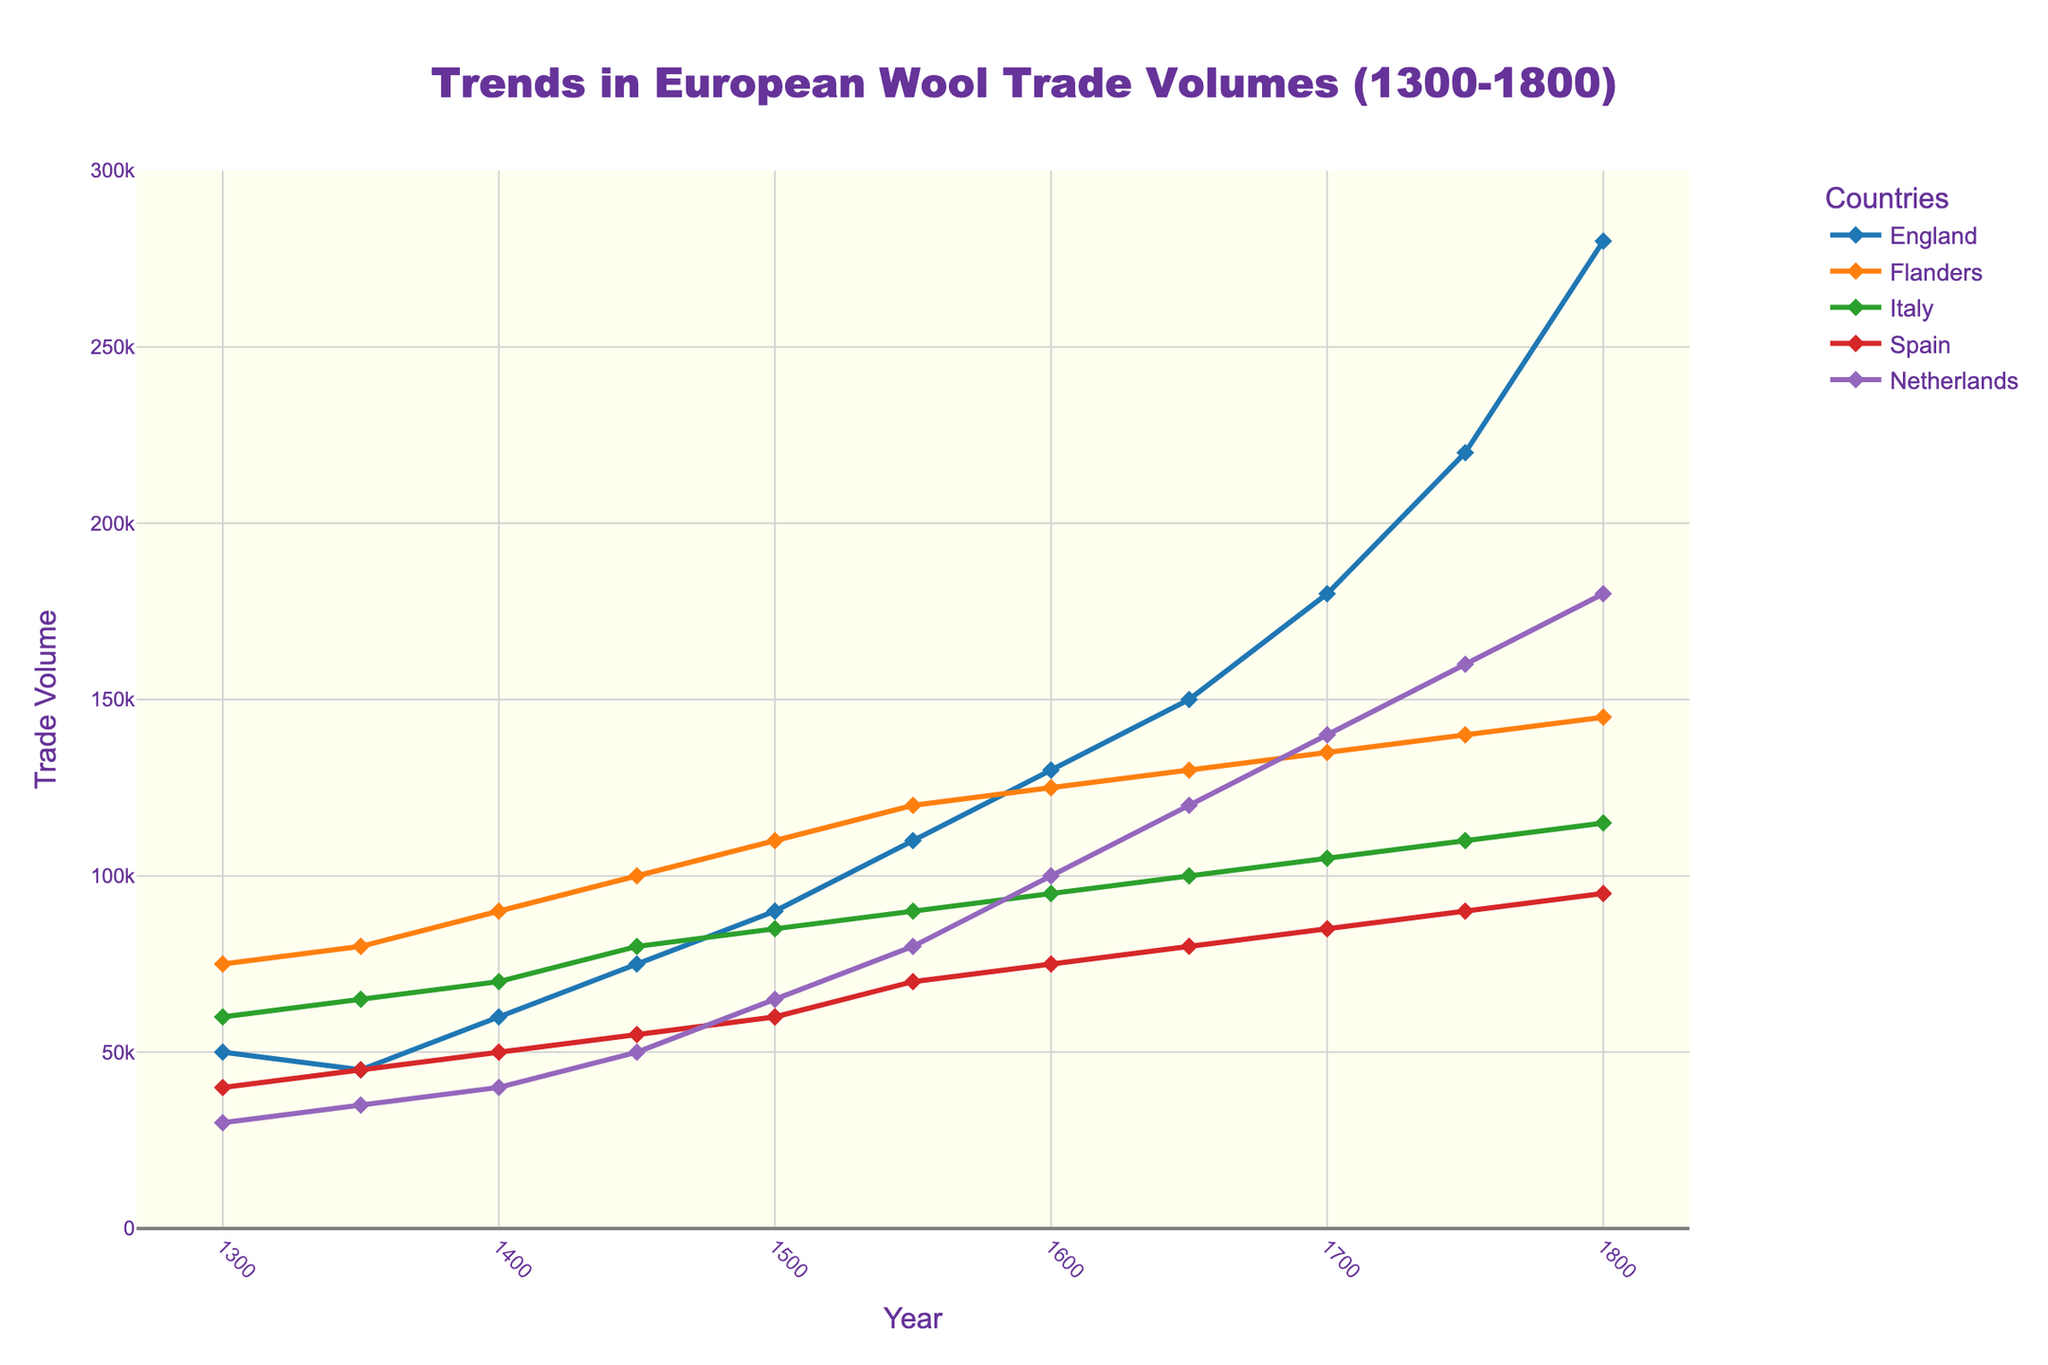Which country had the highest wool trade volume in the year 1500? Each country’s wool trade volume in 1500 can be read from the figure, where the y-axis shows the trade volumes. The trade volumes are as follows: England (90,000), Flanders (110,000), Italy (85,000), Spain (60,000), and Netherlands (65,000). Flanders has the highest volume.
Answer: Flanders What is the total wool trade volume across England, Flanders, and the Netherlands in 1400? Sum the trade volumes for England (60,000), Flanders (90,000), and the Netherlands (40,000) in 1400. The calculation is 60,000 + 90,000 + 40,000 = 190,000.
Answer: 190,000 How does the wool trade volume for Italy compare in 1300 and 1650? Look at the y-axis value for Italy in 1300 (60,000) and compare it to the value in 1650 (100,000). The volume in 1650 is higher by 40,000 (100,000 - 60,000).
Answer: Higher by 40,000 Which country's trade volume shows the steepest increase from 1750 to 1800? Identify the trade volume increase from 1750 to 1800 for each country: England (220,000 to 280,000, increase 60,000), Flanders (140,000 to 145,000, increase 5,000), Italy (110,000 to 115,000, increase 5,000), Spain (90,000 to 95,000, increase 5,000), Netherlands (160,000 to 180,000, increase 20,000). England has the steepest increase.
Answer: England What is the average wool trade volume in 1550 across all listed countries? Calculate the average volume in 1550 by summing the volumes for England (110,000), Flanders (120,000), Italy (90,000), Spain (70,000), and Netherlands (80,000) and then dividing by 5. The calculation is (110,000 + 120,000 + 90,000 + 70,000 + 80,000) / 5 = 94,000.
Answer: 94,000 Which country has the most consistent trade volume growth from 1300 to 1800? Assess the trend lines for each country from 1300 to 1800. A consistent growth line is one that shows a relatively smooth and steady upward trend. Flanders demonstrates the most consistent and steady trade volume growth over the entire period.
Answer: Flanders In which year did Spain’s wool trade volume equal the Netherlands' trade volume in 1300? Find the trade volume for the Netherlands in 1300 (30,000) and identify the year when Spain's volume matches this amount. In 1350, Spain’s volume is 45,000; in 1300, it’s 40,000. It doesn't match exactly, but it’s closest in 1300 with 40,000.
Answer: 1300 